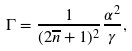Convert formula to latex. <formula><loc_0><loc_0><loc_500><loc_500>\Gamma = \frac { 1 } { ( 2 \overline { n } + 1 ) ^ { 2 } } \frac { \alpha ^ { 2 } } { \gamma } ,</formula> 